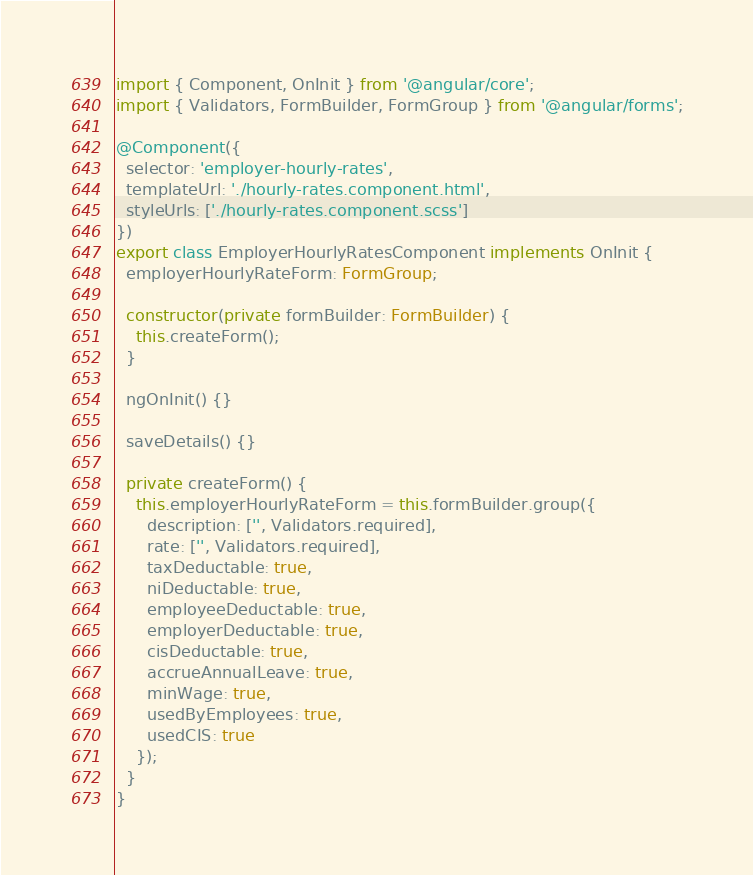<code> <loc_0><loc_0><loc_500><loc_500><_TypeScript_>import { Component, OnInit } from '@angular/core';
import { Validators, FormBuilder, FormGroup } from '@angular/forms';

@Component({
  selector: 'employer-hourly-rates',
  templateUrl: './hourly-rates.component.html',
  styleUrls: ['./hourly-rates.component.scss']
})
export class EmployerHourlyRatesComponent implements OnInit {
  employerHourlyRateForm: FormGroup;

  constructor(private formBuilder: FormBuilder) {
    this.createForm();
  }

  ngOnInit() {}

  saveDetails() {}

  private createForm() {
    this.employerHourlyRateForm = this.formBuilder.group({
      description: ['', Validators.required],
      rate: ['', Validators.required],
      taxDeductable: true,
      niDeductable: true,
      employeeDeductable: true,
      employerDeductable: true,
      cisDeductable: true,
      accrueAnnualLeave: true,
      minWage: true,
      usedByEmployees: true,
      usedCIS: true
    });
  }
}
</code> 